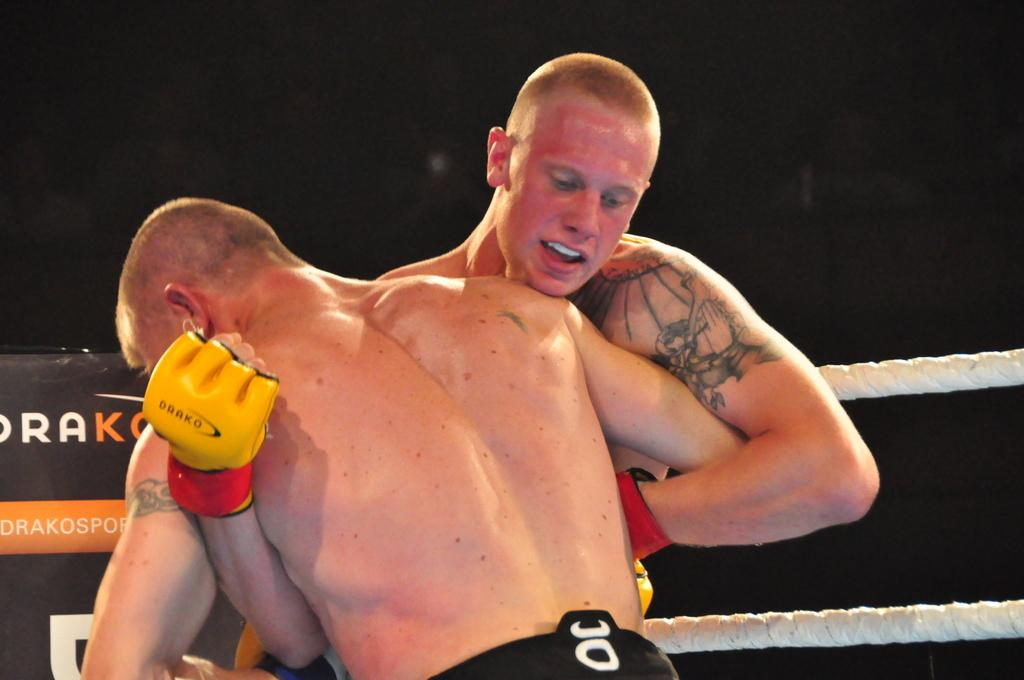How many people are in the image? There are two men in the image. What objects can be seen in the image besides the men? There are ropes and a banner in the image. What is the color of the background in the image? The background of the image is dark. What type of curtain can be seen in the image? There is no curtain present in the image. What is the attraction that the two men are visiting in the image? The image does not provide enough information to determine if the men are visiting an attraction or what that attraction might be. 